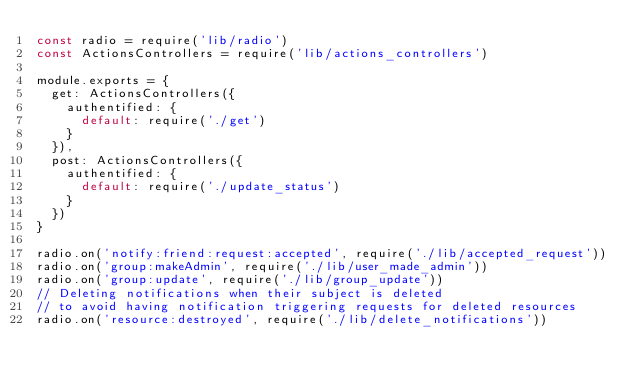Convert code to text. <code><loc_0><loc_0><loc_500><loc_500><_JavaScript_>const radio = require('lib/radio')
const ActionsControllers = require('lib/actions_controllers')

module.exports = {
  get: ActionsControllers({
    authentified: {
      default: require('./get')
    }
  }),
  post: ActionsControllers({
    authentified: {
      default: require('./update_status')
    }
  })
}

radio.on('notify:friend:request:accepted', require('./lib/accepted_request'))
radio.on('group:makeAdmin', require('./lib/user_made_admin'))
radio.on('group:update', require('./lib/group_update'))
// Deleting notifications when their subject is deleted
// to avoid having notification triggering requests for deleted resources
radio.on('resource:destroyed', require('./lib/delete_notifications'))
</code> 